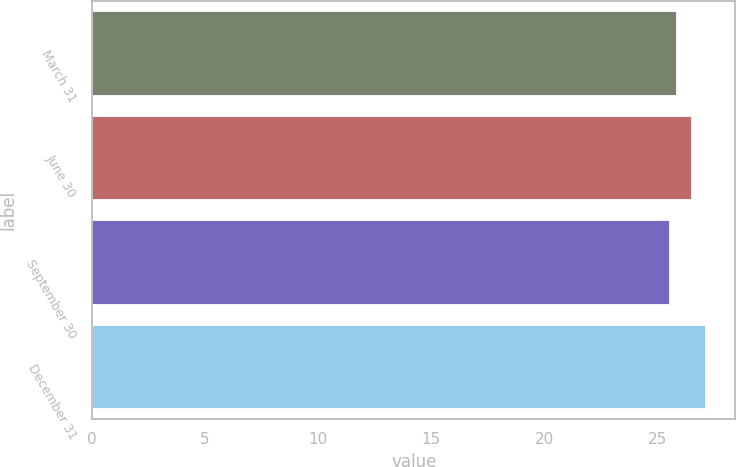Convert chart to OTSL. <chart><loc_0><loc_0><loc_500><loc_500><bar_chart><fcel>March 31<fcel>June 30<fcel>September 30<fcel>December 31<nl><fcel>25.83<fcel>26.48<fcel>25.5<fcel>27.08<nl></chart> 